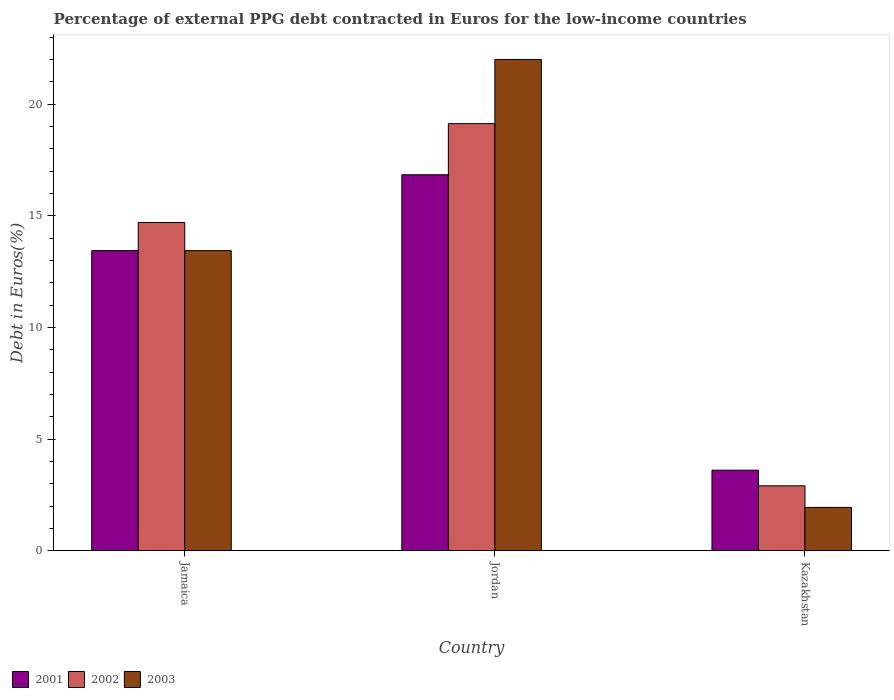How many groups of bars are there?
Your answer should be very brief. 3. Are the number of bars per tick equal to the number of legend labels?
Your answer should be very brief. Yes. What is the label of the 1st group of bars from the left?
Your response must be concise. Jamaica. What is the percentage of external PPG debt contracted in Euros in 2002 in Kazakhstan?
Provide a short and direct response. 2.91. Across all countries, what is the maximum percentage of external PPG debt contracted in Euros in 2001?
Your answer should be very brief. 16.84. Across all countries, what is the minimum percentage of external PPG debt contracted in Euros in 2001?
Your response must be concise. 3.61. In which country was the percentage of external PPG debt contracted in Euros in 2002 maximum?
Your answer should be very brief. Jordan. In which country was the percentage of external PPG debt contracted in Euros in 2002 minimum?
Your answer should be very brief. Kazakhstan. What is the total percentage of external PPG debt contracted in Euros in 2002 in the graph?
Keep it short and to the point. 36.74. What is the difference between the percentage of external PPG debt contracted in Euros in 2002 in Jamaica and that in Kazakhstan?
Give a very brief answer. 11.79. What is the difference between the percentage of external PPG debt contracted in Euros in 2003 in Jordan and the percentage of external PPG debt contracted in Euros in 2001 in Jamaica?
Give a very brief answer. 8.56. What is the average percentage of external PPG debt contracted in Euros in 2002 per country?
Give a very brief answer. 12.25. What is the difference between the percentage of external PPG debt contracted in Euros of/in 2001 and percentage of external PPG debt contracted in Euros of/in 2003 in Kazakhstan?
Make the answer very short. 1.67. In how many countries, is the percentage of external PPG debt contracted in Euros in 2002 greater than 9 %?
Your answer should be compact. 2. What is the ratio of the percentage of external PPG debt contracted in Euros in 2003 in Jordan to that in Kazakhstan?
Your response must be concise. 11.34. What is the difference between the highest and the second highest percentage of external PPG debt contracted in Euros in 2003?
Make the answer very short. -11.5. What is the difference between the highest and the lowest percentage of external PPG debt contracted in Euros in 2002?
Offer a terse response. 16.22. Is the sum of the percentage of external PPG debt contracted in Euros in 2002 in Jamaica and Kazakhstan greater than the maximum percentage of external PPG debt contracted in Euros in 2001 across all countries?
Offer a terse response. Yes. What does the 3rd bar from the left in Kazakhstan represents?
Your response must be concise. 2003. What does the 1st bar from the right in Jamaica represents?
Offer a terse response. 2003. Is it the case that in every country, the sum of the percentage of external PPG debt contracted in Euros in 2001 and percentage of external PPG debt contracted in Euros in 2002 is greater than the percentage of external PPG debt contracted in Euros in 2003?
Ensure brevity in your answer.  Yes. How many bars are there?
Your answer should be very brief. 9. What is the difference between two consecutive major ticks on the Y-axis?
Ensure brevity in your answer.  5. Does the graph contain any zero values?
Your answer should be very brief. No. How are the legend labels stacked?
Offer a terse response. Horizontal. What is the title of the graph?
Your answer should be compact. Percentage of external PPG debt contracted in Euros for the low-income countries. Does "1979" appear as one of the legend labels in the graph?
Make the answer very short. No. What is the label or title of the X-axis?
Provide a short and direct response. Country. What is the label or title of the Y-axis?
Your answer should be compact. Debt in Euros(%). What is the Debt in Euros(%) of 2001 in Jamaica?
Give a very brief answer. 13.44. What is the Debt in Euros(%) of 2002 in Jamaica?
Your response must be concise. 14.7. What is the Debt in Euros(%) in 2003 in Jamaica?
Your response must be concise. 13.44. What is the Debt in Euros(%) of 2001 in Jordan?
Provide a succinct answer. 16.84. What is the Debt in Euros(%) in 2002 in Jordan?
Your answer should be compact. 19.13. What is the Debt in Euros(%) of 2003 in Jordan?
Offer a very short reply. 22. What is the Debt in Euros(%) of 2001 in Kazakhstan?
Your response must be concise. 3.61. What is the Debt in Euros(%) in 2002 in Kazakhstan?
Give a very brief answer. 2.91. What is the Debt in Euros(%) of 2003 in Kazakhstan?
Offer a terse response. 1.94. Across all countries, what is the maximum Debt in Euros(%) in 2001?
Make the answer very short. 16.84. Across all countries, what is the maximum Debt in Euros(%) in 2002?
Keep it short and to the point. 19.13. Across all countries, what is the maximum Debt in Euros(%) of 2003?
Keep it short and to the point. 22. Across all countries, what is the minimum Debt in Euros(%) in 2001?
Offer a terse response. 3.61. Across all countries, what is the minimum Debt in Euros(%) of 2002?
Your answer should be very brief. 2.91. Across all countries, what is the minimum Debt in Euros(%) of 2003?
Provide a short and direct response. 1.94. What is the total Debt in Euros(%) of 2001 in the graph?
Your answer should be compact. 33.89. What is the total Debt in Euros(%) of 2002 in the graph?
Offer a terse response. 36.74. What is the total Debt in Euros(%) of 2003 in the graph?
Offer a very short reply. 37.38. What is the difference between the Debt in Euros(%) of 2001 in Jamaica and that in Jordan?
Provide a short and direct response. -3.4. What is the difference between the Debt in Euros(%) in 2002 in Jamaica and that in Jordan?
Your answer should be very brief. -4.43. What is the difference between the Debt in Euros(%) in 2003 in Jamaica and that in Jordan?
Your response must be concise. -8.56. What is the difference between the Debt in Euros(%) of 2001 in Jamaica and that in Kazakhstan?
Make the answer very short. 9.83. What is the difference between the Debt in Euros(%) in 2002 in Jamaica and that in Kazakhstan?
Your answer should be very brief. 11.79. What is the difference between the Debt in Euros(%) in 2003 in Jamaica and that in Kazakhstan?
Give a very brief answer. 11.5. What is the difference between the Debt in Euros(%) in 2001 in Jordan and that in Kazakhstan?
Your response must be concise. 13.23. What is the difference between the Debt in Euros(%) of 2002 in Jordan and that in Kazakhstan?
Make the answer very short. 16.22. What is the difference between the Debt in Euros(%) in 2003 in Jordan and that in Kazakhstan?
Ensure brevity in your answer.  20.06. What is the difference between the Debt in Euros(%) in 2001 in Jamaica and the Debt in Euros(%) in 2002 in Jordan?
Provide a succinct answer. -5.69. What is the difference between the Debt in Euros(%) in 2001 in Jamaica and the Debt in Euros(%) in 2003 in Jordan?
Offer a terse response. -8.56. What is the difference between the Debt in Euros(%) in 2002 in Jamaica and the Debt in Euros(%) in 2003 in Jordan?
Your answer should be very brief. -7.3. What is the difference between the Debt in Euros(%) in 2001 in Jamaica and the Debt in Euros(%) in 2002 in Kazakhstan?
Ensure brevity in your answer.  10.53. What is the difference between the Debt in Euros(%) of 2001 in Jamaica and the Debt in Euros(%) of 2003 in Kazakhstan?
Keep it short and to the point. 11.5. What is the difference between the Debt in Euros(%) in 2002 in Jamaica and the Debt in Euros(%) in 2003 in Kazakhstan?
Offer a very short reply. 12.76. What is the difference between the Debt in Euros(%) in 2001 in Jordan and the Debt in Euros(%) in 2002 in Kazakhstan?
Make the answer very short. 13.93. What is the difference between the Debt in Euros(%) of 2001 in Jordan and the Debt in Euros(%) of 2003 in Kazakhstan?
Your answer should be very brief. 14.9. What is the difference between the Debt in Euros(%) of 2002 in Jordan and the Debt in Euros(%) of 2003 in Kazakhstan?
Provide a short and direct response. 17.19. What is the average Debt in Euros(%) in 2001 per country?
Provide a short and direct response. 11.3. What is the average Debt in Euros(%) in 2002 per country?
Your response must be concise. 12.25. What is the average Debt in Euros(%) in 2003 per country?
Your answer should be very brief. 12.46. What is the difference between the Debt in Euros(%) of 2001 and Debt in Euros(%) of 2002 in Jamaica?
Provide a short and direct response. -1.26. What is the difference between the Debt in Euros(%) in 2001 and Debt in Euros(%) in 2003 in Jamaica?
Offer a terse response. 0. What is the difference between the Debt in Euros(%) of 2002 and Debt in Euros(%) of 2003 in Jamaica?
Your answer should be very brief. 1.26. What is the difference between the Debt in Euros(%) of 2001 and Debt in Euros(%) of 2002 in Jordan?
Keep it short and to the point. -2.29. What is the difference between the Debt in Euros(%) of 2001 and Debt in Euros(%) of 2003 in Jordan?
Your response must be concise. -5.17. What is the difference between the Debt in Euros(%) of 2002 and Debt in Euros(%) of 2003 in Jordan?
Keep it short and to the point. -2.87. What is the difference between the Debt in Euros(%) of 2001 and Debt in Euros(%) of 2002 in Kazakhstan?
Offer a very short reply. 0.7. What is the difference between the Debt in Euros(%) of 2001 and Debt in Euros(%) of 2003 in Kazakhstan?
Keep it short and to the point. 1.67. What is the ratio of the Debt in Euros(%) in 2001 in Jamaica to that in Jordan?
Your response must be concise. 0.8. What is the ratio of the Debt in Euros(%) in 2002 in Jamaica to that in Jordan?
Make the answer very short. 0.77. What is the ratio of the Debt in Euros(%) in 2003 in Jamaica to that in Jordan?
Ensure brevity in your answer.  0.61. What is the ratio of the Debt in Euros(%) in 2001 in Jamaica to that in Kazakhstan?
Your answer should be compact. 3.73. What is the ratio of the Debt in Euros(%) of 2002 in Jamaica to that in Kazakhstan?
Ensure brevity in your answer.  5.06. What is the ratio of the Debt in Euros(%) of 2003 in Jamaica to that in Kazakhstan?
Provide a succinct answer. 6.93. What is the ratio of the Debt in Euros(%) in 2001 in Jordan to that in Kazakhstan?
Your answer should be very brief. 4.67. What is the ratio of the Debt in Euros(%) in 2002 in Jordan to that in Kazakhstan?
Your response must be concise. 6.58. What is the ratio of the Debt in Euros(%) in 2003 in Jordan to that in Kazakhstan?
Offer a very short reply. 11.34. What is the difference between the highest and the second highest Debt in Euros(%) of 2001?
Your answer should be very brief. 3.4. What is the difference between the highest and the second highest Debt in Euros(%) in 2002?
Make the answer very short. 4.43. What is the difference between the highest and the second highest Debt in Euros(%) in 2003?
Offer a very short reply. 8.56. What is the difference between the highest and the lowest Debt in Euros(%) in 2001?
Offer a terse response. 13.23. What is the difference between the highest and the lowest Debt in Euros(%) of 2002?
Offer a terse response. 16.22. What is the difference between the highest and the lowest Debt in Euros(%) in 2003?
Your answer should be compact. 20.06. 